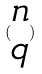<formula> <loc_0><loc_0><loc_500><loc_500>( \begin{matrix} n \\ q \end{matrix} )</formula> 